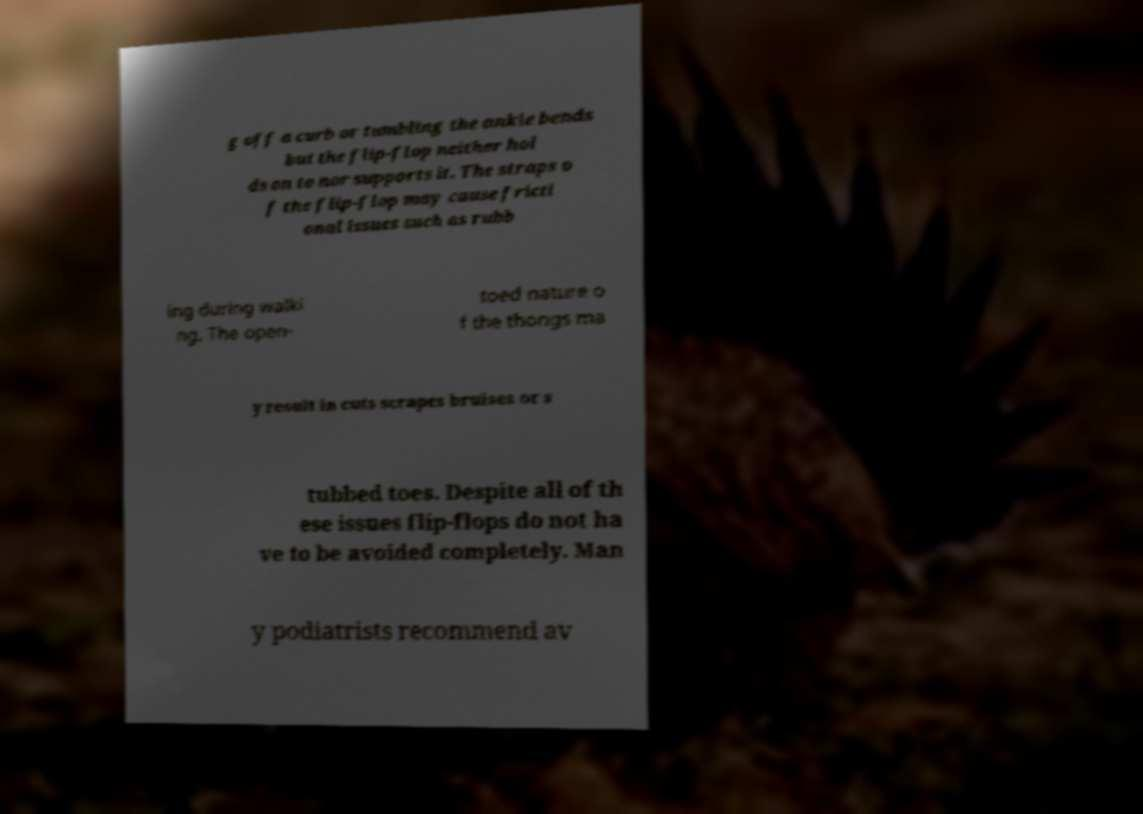What messages or text are displayed in this image? I need them in a readable, typed format. g off a curb or tumbling the ankle bends but the flip-flop neither hol ds on to nor supports it. The straps o f the flip-flop may cause fricti onal issues such as rubb ing during walki ng. The open- toed nature o f the thongs ma y result in cuts scrapes bruises or s tubbed toes. Despite all of th ese issues flip-flops do not ha ve to be avoided completely. Man y podiatrists recommend av 